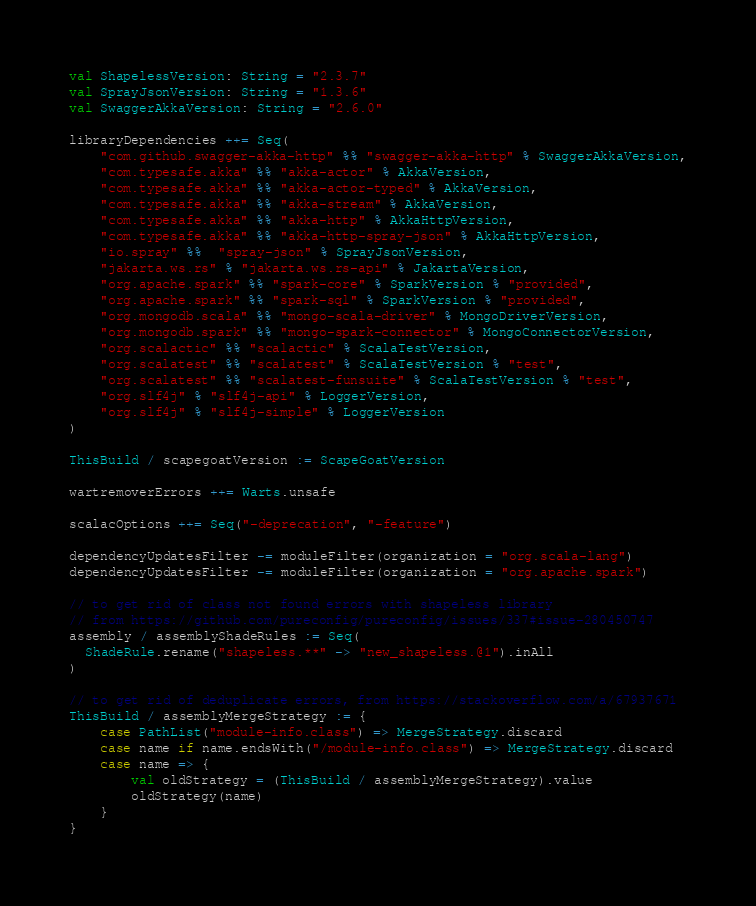Convert code to text. <code><loc_0><loc_0><loc_500><loc_500><_Scala_>val ShapelessVersion: String = "2.3.7"
val SprayJsonVersion: String = "1.3.6"
val SwaggerAkkaVersion: String = "2.6.0"

libraryDependencies ++= Seq(
    "com.github.swagger-akka-http" %% "swagger-akka-http" % SwaggerAkkaVersion,
    "com.typesafe.akka" %% "akka-actor" % AkkaVersion,
    "com.typesafe.akka" %% "akka-actor-typed" % AkkaVersion,
    "com.typesafe.akka" %% "akka-stream" % AkkaVersion,
    "com.typesafe.akka" %% "akka-http" % AkkaHttpVersion,
    "com.typesafe.akka" %% "akka-http-spray-json" % AkkaHttpVersion,
    "io.spray" %%  "spray-json" % SprayJsonVersion,
    "jakarta.ws.rs" % "jakarta.ws.rs-api" % JakartaVersion,
    "org.apache.spark" %% "spark-core" % SparkVersion % "provided",
    "org.apache.spark" %% "spark-sql" % SparkVersion % "provided",
    "org.mongodb.scala" %% "mongo-scala-driver" % MongoDriverVersion,
    "org.mongodb.spark" %% "mongo-spark-connector" % MongoConnectorVersion,
    "org.scalactic" %% "scalactic" % ScalaTestVersion,
    "org.scalatest" %% "scalatest" % ScalaTestVersion % "test",
    "org.scalatest" %% "scalatest-funsuite" % ScalaTestVersion % "test",
    "org.slf4j" % "slf4j-api" % LoggerVersion,
    "org.slf4j" % "slf4j-simple" % LoggerVersion
)

ThisBuild / scapegoatVersion := ScapeGoatVersion

wartremoverErrors ++= Warts.unsafe

scalacOptions ++= Seq("-deprecation", "-feature")

dependencyUpdatesFilter -= moduleFilter(organization = "org.scala-lang")
dependencyUpdatesFilter -= moduleFilter(organization = "org.apache.spark")

// to get rid of class not found errors with shapeless library
// from https://github.com/pureconfig/pureconfig/issues/337#issue-280450747
assembly / assemblyShadeRules := Seq(
  ShadeRule.rename("shapeless.**" -> "new_shapeless.@1").inAll
)

// to get rid of deduplicate errors, from https://stackoverflow.com/a/67937671
ThisBuild / assemblyMergeStrategy := {
    case PathList("module-info.class") => MergeStrategy.discard
    case name if name.endsWith("/module-info.class") => MergeStrategy.discard
    case name => {
        val oldStrategy = (ThisBuild / assemblyMergeStrategy).value
        oldStrategy(name)
    }
}
</code> 